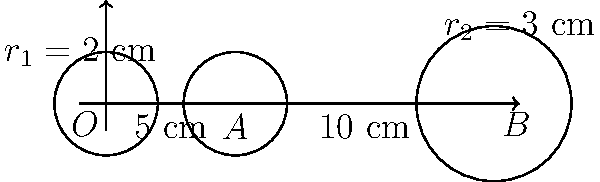In a textile mill, two pulleys of different sizes need to be connected by a belt. The centers of the pulleys are 15 cm apart. The first pulley has a radius of 2 cm and is located at points O and A, 5 cm apart. The second pulley has a radius of 3 cm and is located at point B. Calculate the minimum length of the belt needed to connect these pulleys, assuming the belt forms a tangent line between them. To find the minimum length of the belt, we need to calculate:
1. The length of the tangent lines between the pulleys
2. The length of the arc on each pulley that the belt covers

Step 1: Calculate the distance between the centers of the pulleys
$OB = 15$ cm

Step 2: Calculate the difference in radii
$r_2 - r_1 = 3 - 2 = 1$ cm

Step 3: Calculate the length of the tangent line using the Pythagorean theorem
$$L_{tangent} = \sqrt{OB^2 - (r_2 - r_1)^2} = \sqrt{15^2 - 1^2} = \sqrt{224} \approx 14.97 \text{ cm}$$

Step 4: Calculate the angles subtended by the tangent lines at the center of each pulley
$$\sin \theta_1 = \frac{r_2 - r_1}{OB} = \frac{1}{15}$$
$$\theta_1 = \arcsin(\frac{1}{15}) \approx 0.0667 \text{ radians}$$
$$\theta_2 = \pi - 2\theta_1 \approx 3.0082 \text{ radians}$$

Step 5: Calculate the length of the arc on each pulley
$$L_{arc1} = 2 \cdot r_1 \cdot \theta_1 = 2 \cdot 2 \cdot 0.0667 \approx 0.2668 \text{ cm}$$
$$L_{arc2} = r_2 \cdot \theta_2 = 3 \cdot 3.0082 \approx 9.0246 \text{ cm}$$

Step 6: Calculate the total length of the belt
$$L_{total} = 2 \cdot L_{tangent} + L_{arc1} + L_{arc2}$$
$$L_{total} = 2 \cdot 14.97 + 0.2668 + 9.0246 \approx 39.2314 \text{ cm}$$
Answer: $39.23 \text{ cm}$ 